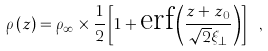Convert formula to latex. <formula><loc_0><loc_0><loc_500><loc_500>\rho \left ( z \right ) = \rho _ { \infty } \times \frac { 1 } { 2 } \left [ 1 + \text {erf} \left ( \frac { z + z _ { 0 } } { \sqrt { 2 } \xi _ { \perp } } \right ) \right ] \ ,</formula> 